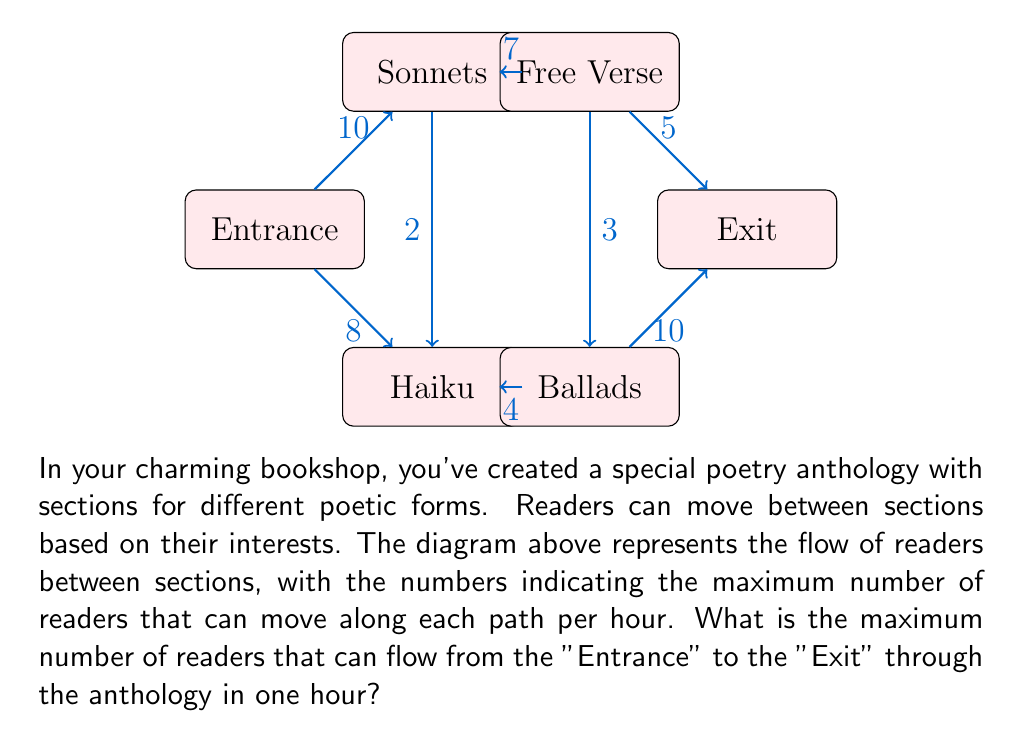Solve this math problem. To solve this maximum flow problem, we'll use the Ford-Fulkerson algorithm:

1) Start with zero flow on all edges.

2) Find an augmenting path from Entrance to Exit:
   Entrance → Sonnets → Free Verse → Exit (capacity 5)
   Increase flow by 5.

3) Find another augmenting path:
   Entrance → Haiku → Ballads → Exit (capacity 8)
   Increase flow by 8.

4) Find another augmenting path:
   Entrance → Sonnets → Haiku → Ballads → Exit
   Capacity is min(5, 2, 6, 2) = 2
   Increase flow by 2.

5) No more augmenting paths exist.

The maximum flow is the sum of all flow increases:
$$ 5 + 8 + 2 = 15 $$

To verify:
- Flow from Entrance: 7 to Sonnets, 8 to Haiku (total 15)
- Flow to Exit: 5 from Free Verse, 10 from Ballads (total 15)

Conservation of flow is maintained at all intermediate nodes.
Answer: The maximum flow of readers from the Entrance to the Exit through the poetry anthology is 15 readers per hour. 